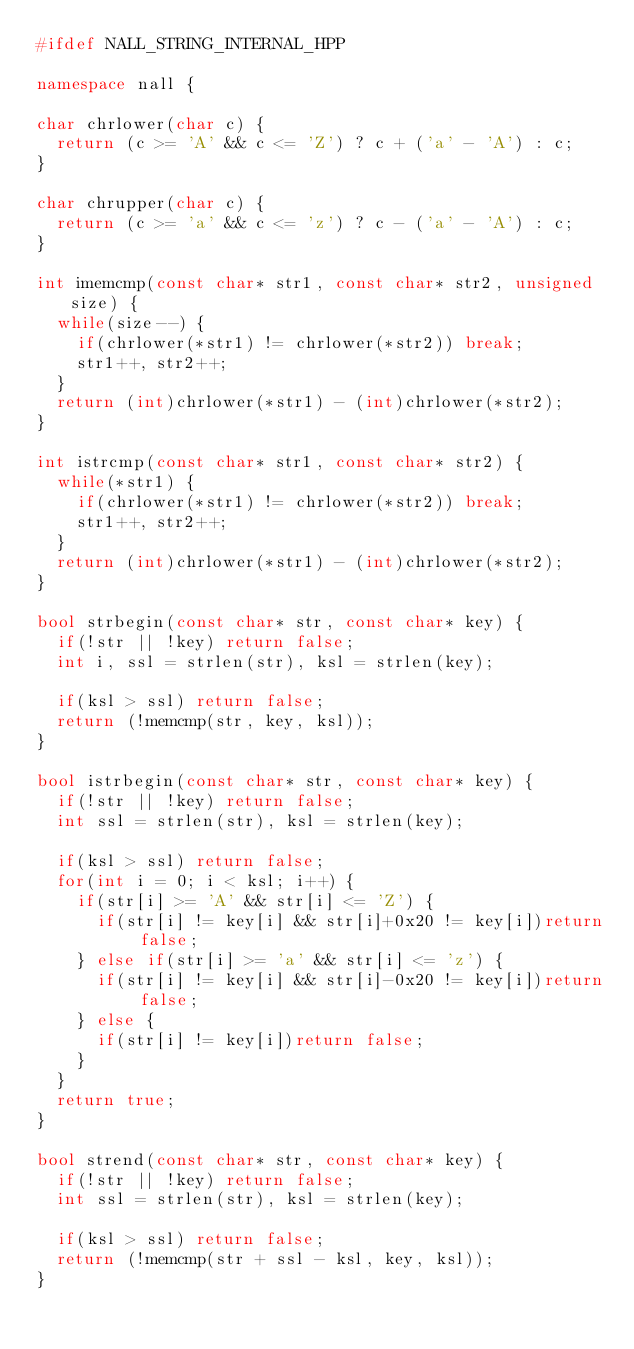<code> <loc_0><loc_0><loc_500><loc_500><_C++_>#ifdef NALL_STRING_INTERNAL_HPP

namespace nall {

char chrlower(char c) {
  return (c >= 'A' && c <= 'Z') ? c + ('a' - 'A') : c;
}

char chrupper(char c) {
  return (c >= 'a' && c <= 'z') ? c - ('a' - 'A') : c;
}

int imemcmp(const char* str1, const char* str2, unsigned size) {
  while(size--) {
    if(chrlower(*str1) != chrlower(*str2)) break;
    str1++, str2++;
  }
  return (int)chrlower(*str1) - (int)chrlower(*str2);
}

int istrcmp(const char* str1, const char* str2) {
  while(*str1) {
    if(chrlower(*str1) != chrlower(*str2)) break;
    str1++, str2++;
  }
  return (int)chrlower(*str1) - (int)chrlower(*str2);
}

bool strbegin(const char* str, const char* key) {
  if(!str || !key) return false;
  int i, ssl = strlen(str), ksl = strlen(key);

  if(ksl > ssl) return false;
  return (!memcmp(str, key, ksl));
}

bool istrbegin(const char* str, const char* key) {
  if(!str || !key) return false;
  int ssl = strlen(str), ksl = strlen(key);

  if(ksl > ssl) return false;
  for(int i = 0; i < ksl; i++) {
    if(str[i] >= 'A' && str[i] <= 'Z') {
      if(str[i] != key[i] && str[i]+0x20 != key[i])return false;
    } else if(str[i] >= 'a' && str[i] <= 'z') {
      if(str[i] != key[i] && str[i]-0x20 != key[i])return false;
    } else {
      if(str[i] != key[i])return false;
    }
  }
  return true;
}

bool strend(const char* str, const char* key) {
  if(!str || !key) return false;
  int ssl = strlen(str), ksl = strlen(key);

  if(ksl > ssl) return false;
  return (!memcmp(str + ssl - ksl, key, ksl));
}
</code> 